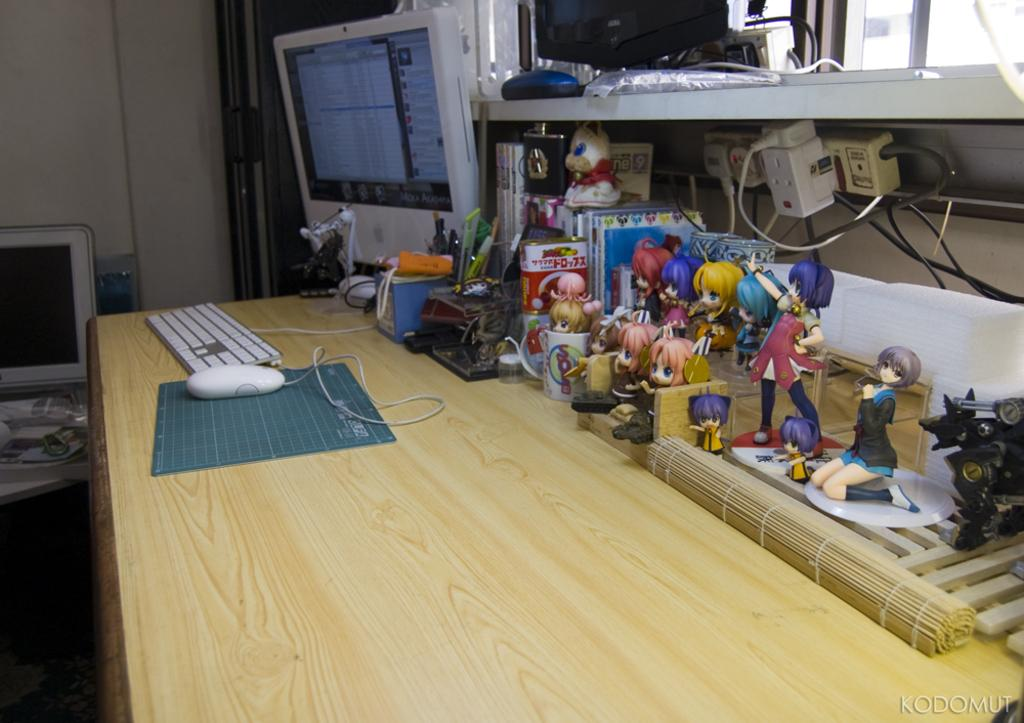What type of structure can be seen in the image? The image contains a wall. What electronic devices are visible in the image? There are screens and a keyboard present in the image. What furniture is in the image? There is a table in the image. What items are on the table? A keyboard, a mouse, a mouse pad, and different types of dolls are on the table. What type of outlets are in the image? There are sockets in the image. What architectural feature is visible in the image? There is a window in the image. What type of food is being prepared in the image? There is no food preparation visible in the image. What type of mist is covering the screens in the image? There is no mist present in the image; the screens are clear. 